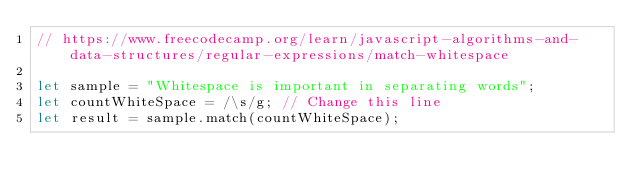<code> <loc_0><loc_0><loc_500><loc_500><_JavaScript_>// https://www.freecodecamp.org/learn/javascript-algorithms-and-data-structures/regular-expressions/match-whitespace

let sample = "Whitespace is important in separating words";
let countWhiteSpace = /\s/g; // Change this line
let result = sample.match(countWhiteSpace);</code> 